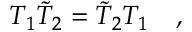Convert formula to latex. <formula><loc_0><loc_0><loc_500><loc_500>T _ { 1 } \tilde { T } _ { 2 } = \tilde { T } _ { 2 } T _ { 1 } \quad ,</formula> 